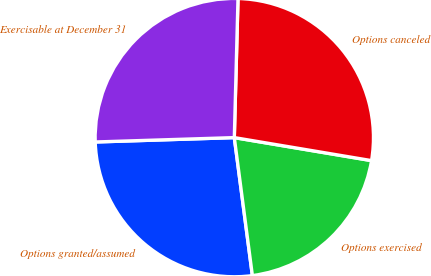Convert chart. <chart><loc_0><loc_0><loc_500><loc_500><pie_chart><fcel>Options granted/assumed<fcel>Options exercised<fcel>Options canceled<fcel>Exercisable at December 31<nl><fcel>26.57%<fcel>20.28%<fcel>27.22%<fcel>25.92%<nl></chart> 